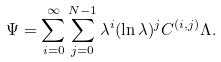<formula> <loc_0><loc_0><loc_500><loc_500>\Psi = \sum _ { i = 0 } ^ { \infty } \sum _ { j = 0 } ^ { N - 1 } \lambda ^ { i } ( \ln \lambda ) ^ { j } C ^ { ( i , j ) } \Lambda .</formula> 